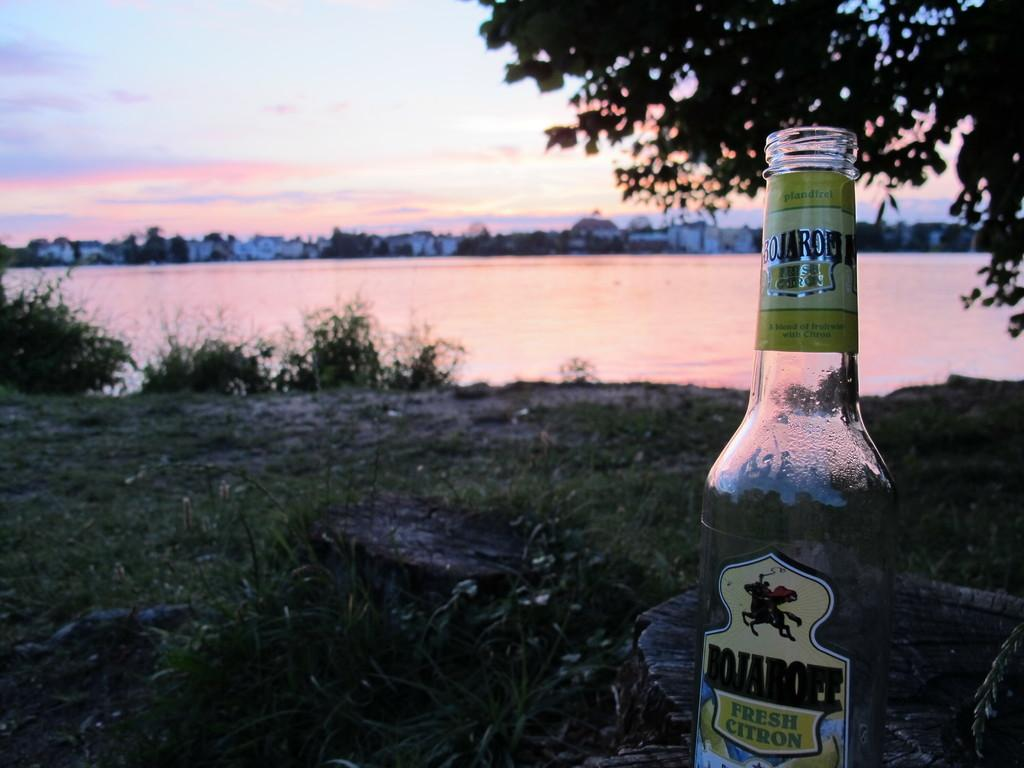What object can be seen in the image? There is a bottle in the image. What can be seen in the background of the image? There is a tree and water visible in the background of the image. What else is visible in the background of the image? The sky is visible in the background of the image. Can you see a rabbit helping the baby in the image? There is no rabbit or baby present in the image. 